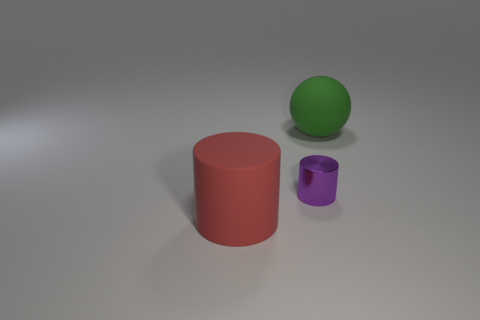Add 3 purple metal cylinders. How many objects exist? 6 Subtract all cylinders. How many objects are left? 1 Subtract all green rubber spheres. Subtract all purple things. How many objects are left? 1 Add 2 big red rubber objects. How many big red rubber objects are left? 3 Add 1 big blue metallic cylinders. How many big blue metallic cylinders exist? 1 Subtract 0 blue spheres. How many objects are left? 3 